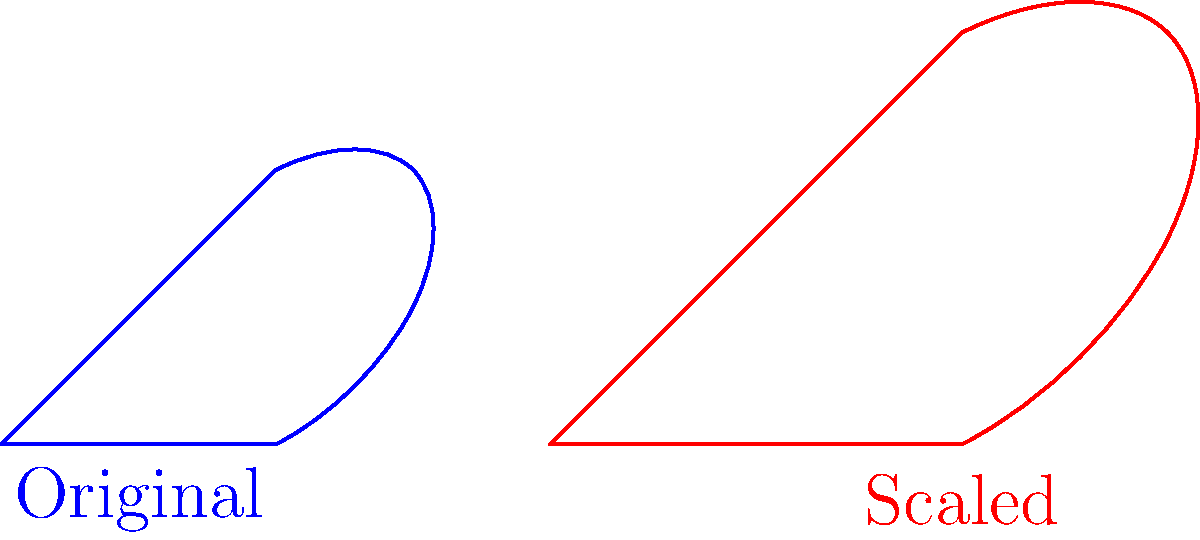As a baseball coach who has worked with professional players, you understand the importance of bat dimensions. If we scale the dimensions of a standard baseball bat by a factor of 1.5, how will this affect the bat's surface area? Express your answer as a ratio of the new surface area to the original surface area. Let's approach this step-by-step:

1) When we scale a two-dimensional shape, the scaling factor affects both dimensions (length and width).

2) The surface area is calculated by multiplying these two dimensions.

3) In this case, both dimensions are scaled by a factor of 1.5.

4) To find the new surface area relative to the original, we multiply these scaling factors:

   $1.5 \times 1.5 = 2.25$

5) This means that the new surface area is 2.25 times the original surface area.

6) We can express this as a ratio: $\frac{\text{New Area}}{\text{Original Area}} = \frac{2.25}{1} = 2.25:1$

Therefore, the surface area of the scaled bat is 2.25 times the surface area of the original bat.
Answer: $2.25:1$ 